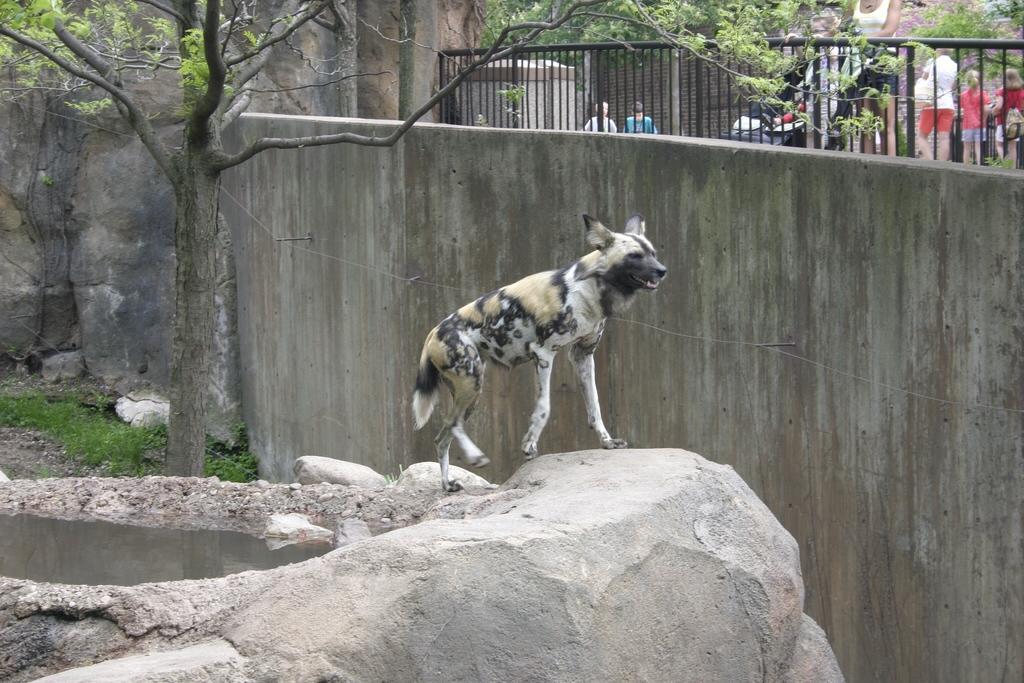How would you summarize this image in a sentence or two? In this image we can see an animal, there are a few people, there are rocks, water, trees, grass, also we can see the wall. 